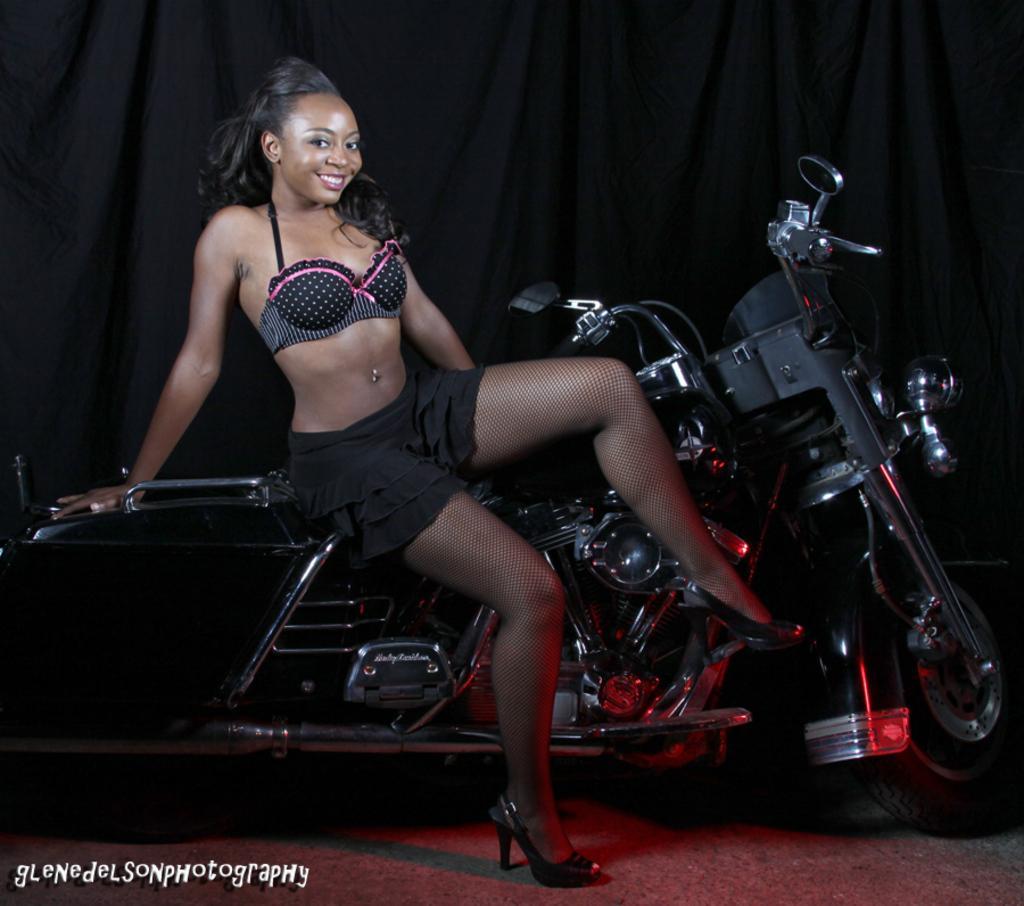In one or two sentences, can you explain what this image depicts? In this picture there is a woman sitting on a bike 